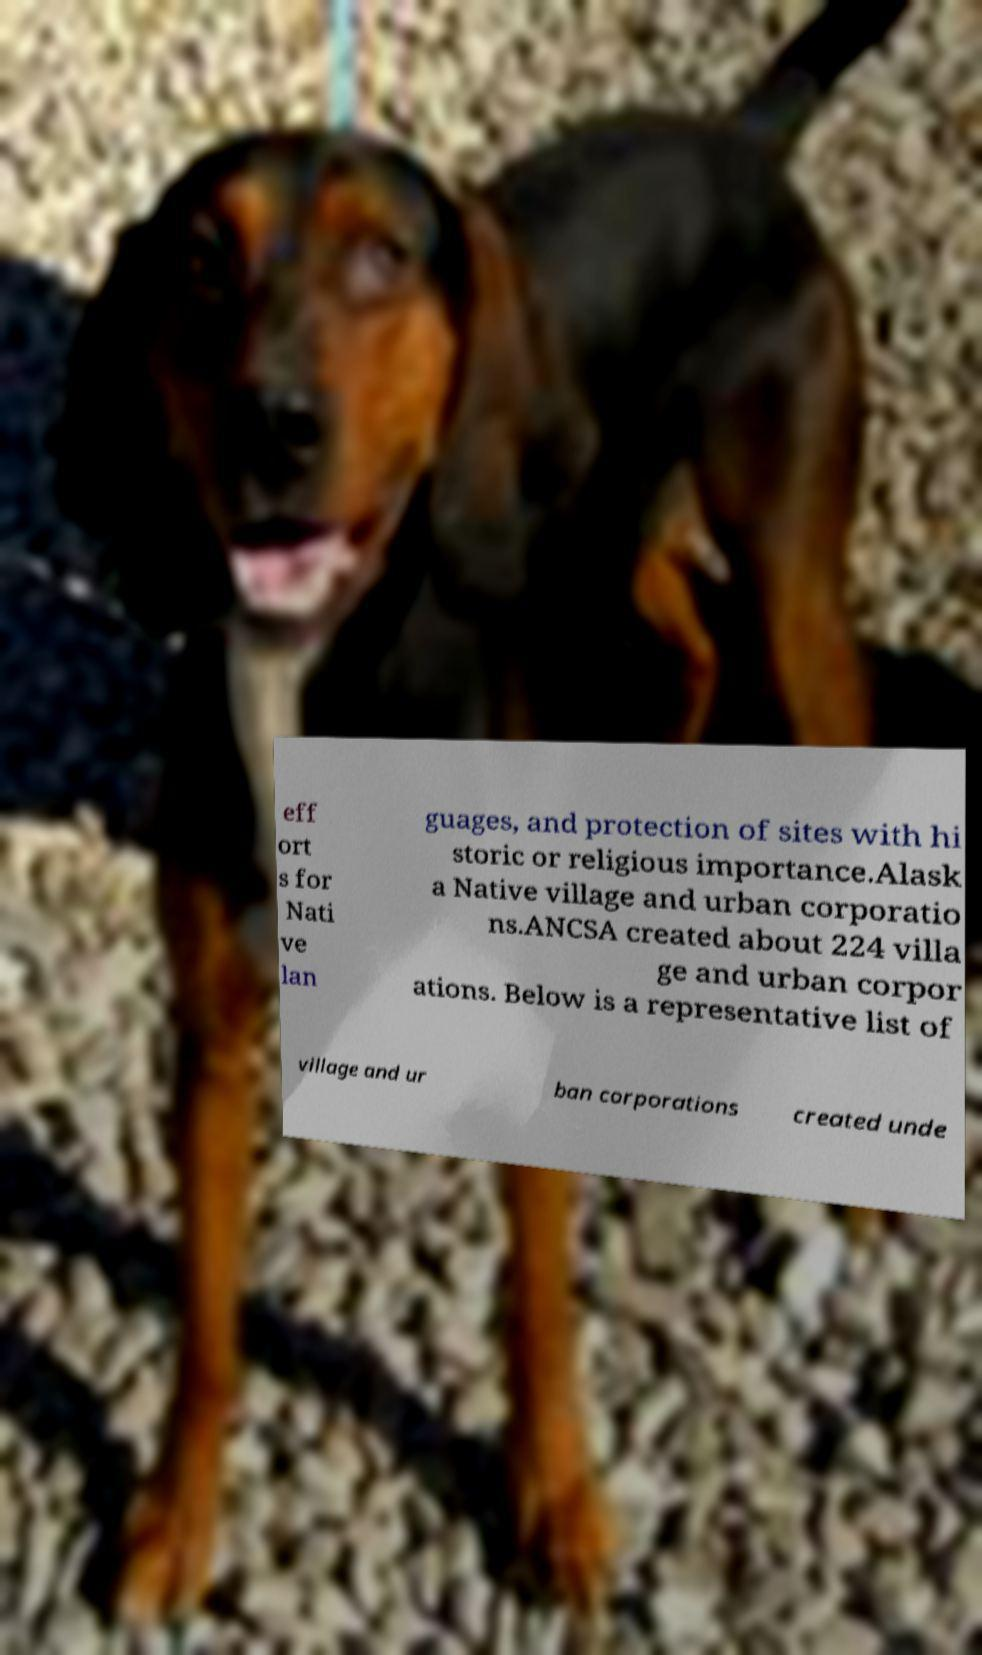Could you assist in decoding the text presented in this image and type it out clearly? eff ort s for Nati ve lan guages, and protection of sites with hi storic or religious importance.Alask a Native village and urban corporatio ns.ANCSA created about 224 villa ge and urban corpor ations. Below is a representative list of village and ur ban corporations created unde 